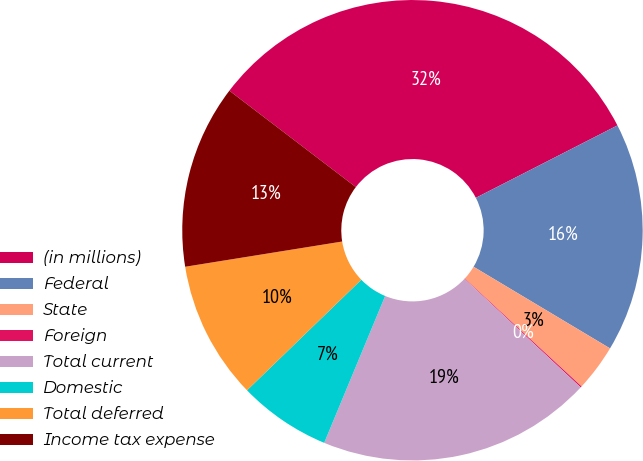<chart> <loc_0><loc_0><loc_500><loc_500><pie_chart><fcel>(in millions)<fcel>Federal<fcel>State<fcel>Foreign<fcel>Total current<fcel>Domestic<fcel>Total deferred<fcel>Income tax expense<nl><fcel>32.11%<fcel>16.1%<fcel>3.29%<fcel>0.09%<fcel>19.3%<fcel>6.5%<fcel>9.7%<fcel>12.9%<nl></chart> 